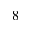Convert formula to latex. <formula><loc_0><loc_0><loc_500><loc_500>^ { 8 }</formula> 